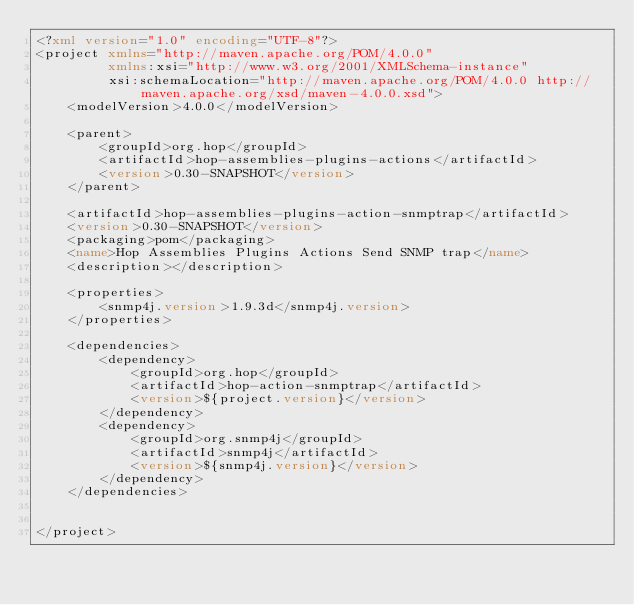Convert code to text. <code><loc_0><loc_0><loc_500><loc_500><_XML_><?xml version="1.0" encoding="UTF-8"?>
<project xmlns="http://maven.apache.org/POM/4.0.0"
         xmlns:xsi="http://www.w3.org/2001/XMLSchema-instance"
         xsi:schemaLocation="http://maven.apache.org/POM/4.0.0 http://maven.apache.org/xsd/maven-4.0.0.xsd">
    <modelVersion>4.0.0</modelVersion>

    <parent>
        <groupId>org.hop</groupId>
        <artifactId>hop-assemblies-plugins-actions</artifactId>
        <version>0.30-SNAPSHOT</version>
    </parent>

    <artifactId>hop-assemblies-plugins-action-snmptrap</artifactId>
    <version>0.30-SNAPSHOT</version>
    <packaging>pom</packaging>
    <name>Hop Assemblies Plugins Actions Send SNMP trap</name>
    <description></description>

	<properties>
		<snmp4j.version>1.9.3d</snmp4j.version>
	</properties>

	<dependencies>
        <dependency>
            <groupId>org.hop</groupId>
            <artifactId>hop-action-snmptrap</artifactId>
            <version>${project.version}</version>
        </dependency>	
		<dependency>
			<groupId>org.snmp4j</groupId>
			<artifactId>snmp4j</artifactId>
			<version>${snmp4j.version}</version>
		</dependency>
	</dependencies>

    
</project></code> 